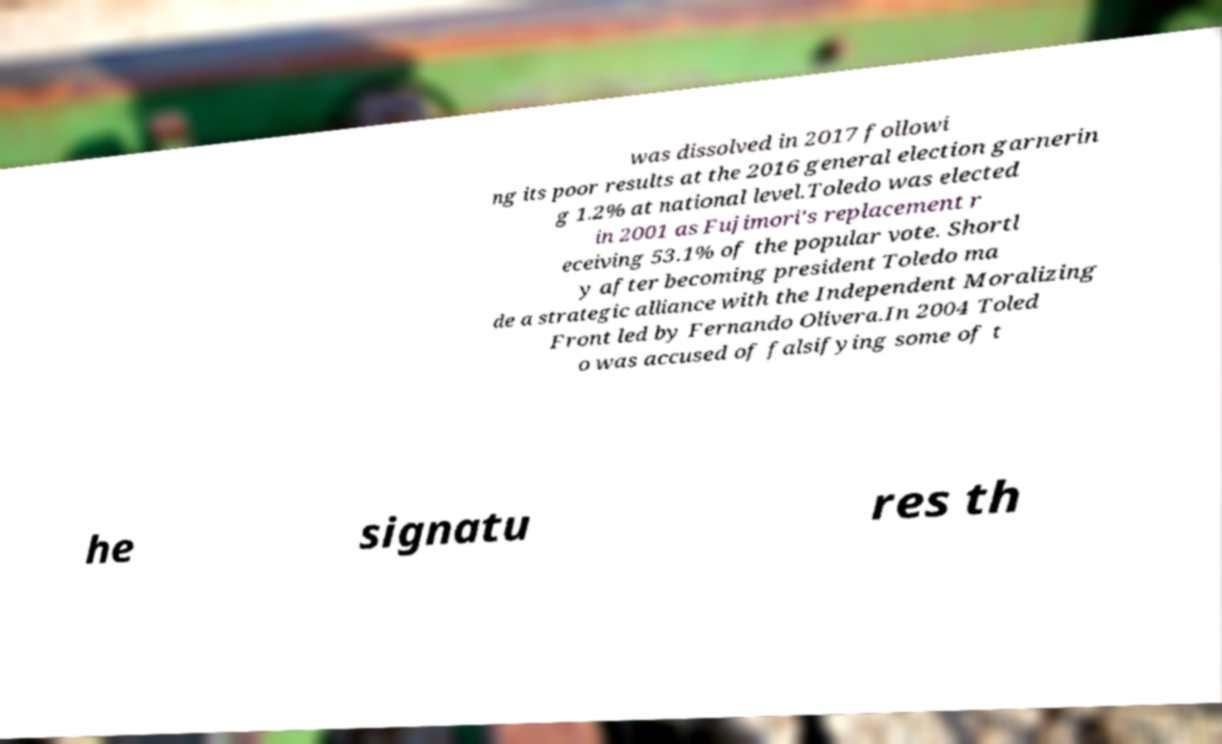For documentation purposes, I need the text within this image transcribed. Could you provide that? was dissolved in 2017 followi ng its poor results at the 2016 general election garnerin g 1.2% at national level.Toledo was elected in 2001 as Fujimori's replacement r eceiving 53.1% of the popular vote. Shortl y after becoming president Toledo ma de a strategic alliance with the Independent Moralizing Front led by Fernando Olivera.In 2004 Toled o was accused of falsifying some of t he signatu res th 